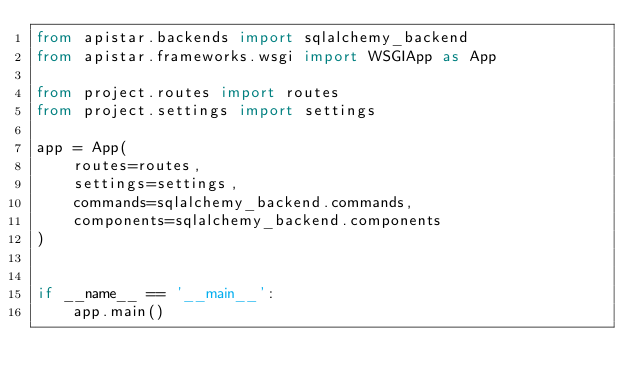<code> <loc_0><loc_0><loc_500><loc_500><_Python_>from apistar.backends import sqlalchemy_backend
from apistar.frameworks.wsgi import WSGIApp as App

from project.routes import routes
from project.settings import settings

app = App(
    routes=routes,
    settings=settings,
    commands=sqlalchemy_backend.commands,
    components=sqlalchemy_backend.components
)


if __name__ == '__main__':
    app.main()
</code> 